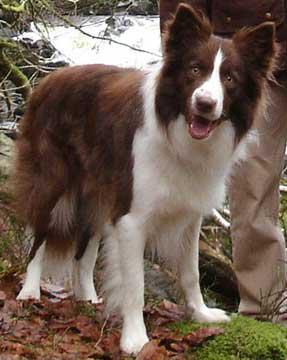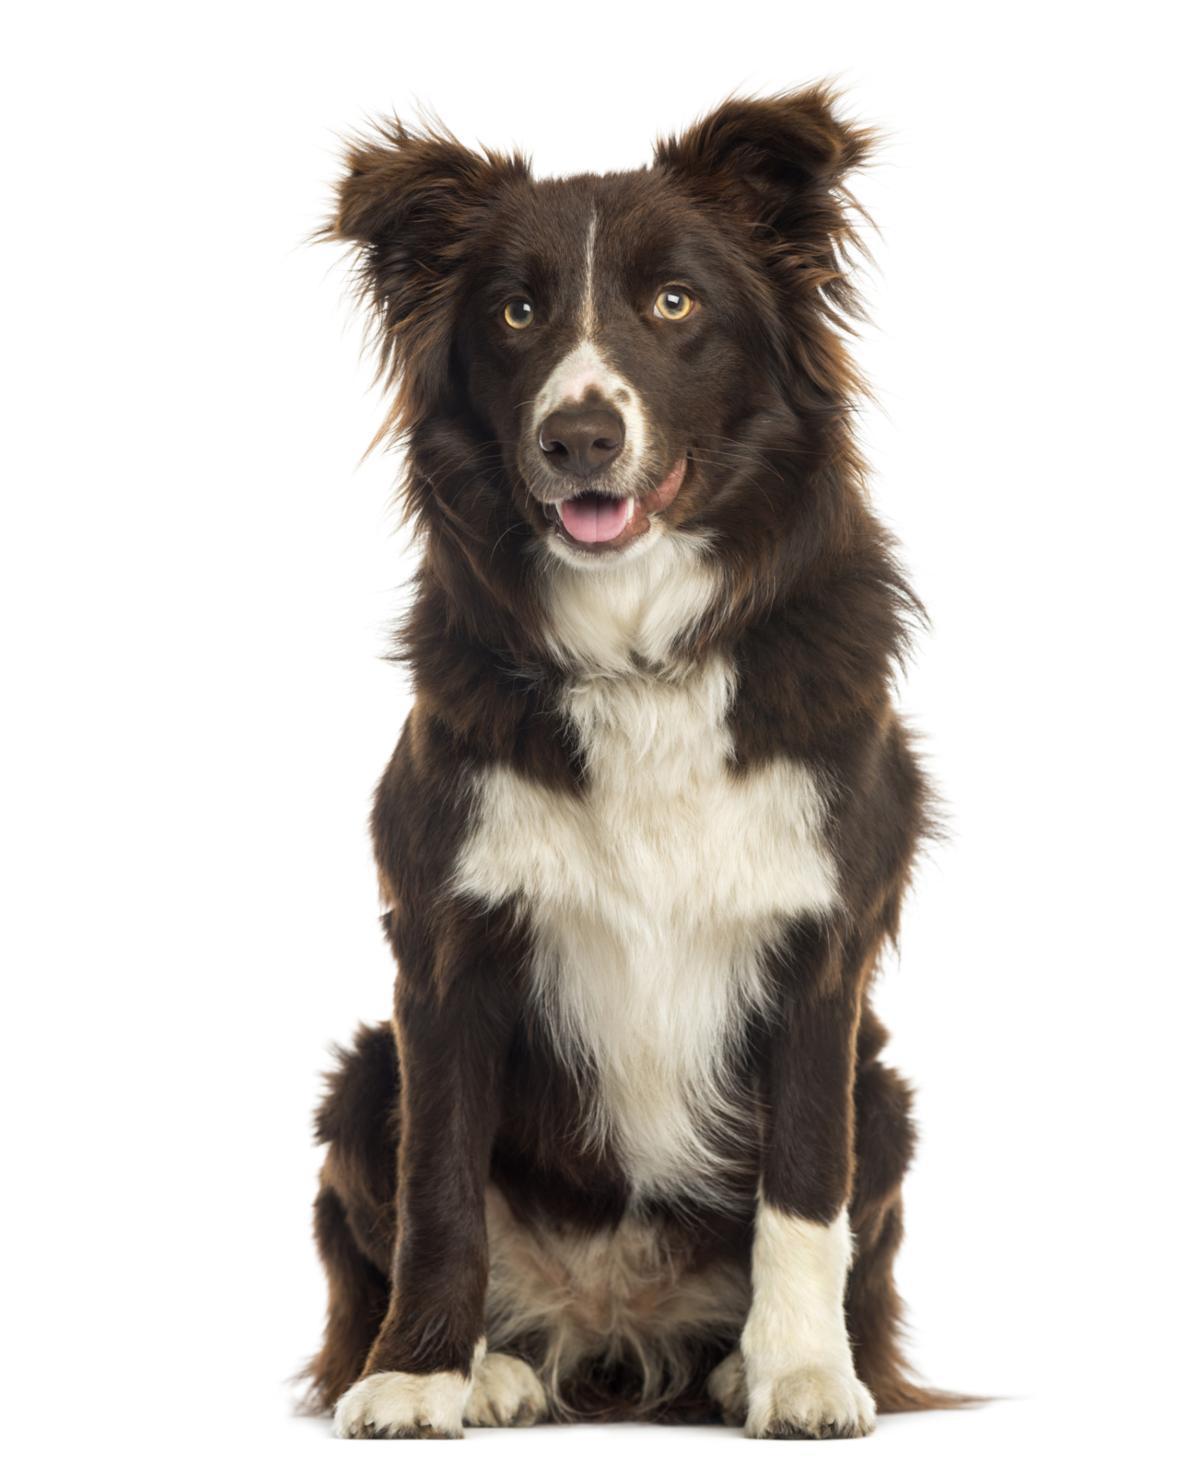The first image is the image on the left, the second image is the image on the right. Analyze the images presented: Is the assertion "The dog in the image on the left is standing outside." valid? Answer yes or no. Yes. The first image is the image on the left, the second image is the image on the right. Considering the images on both sides, is "The lefthand image shows a non-standing, frontward-facing brown and white dog with non-erect erects." valid? Answer yes or no. No. 